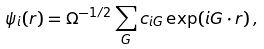Convert formula to latex. <formula><loc_0><loc_0><loc_500><loc_500>\psi _ { i } ( { r } ) = \Omega ^ { - 1 / 2 } \sum _ { G } c _ { i { G } } \exp ( i { G } \cdot { r } ) \, ,</formula> 